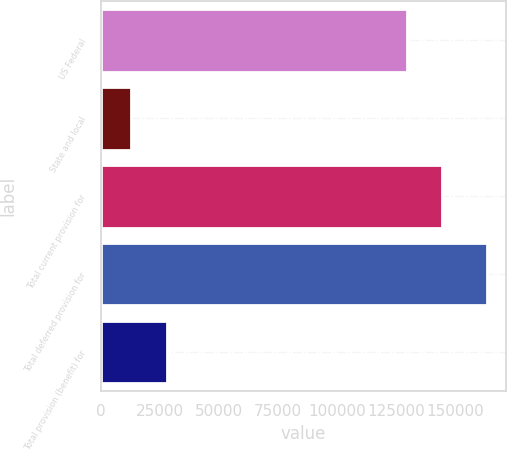Convert chart. <chart><loc_0><loc_0><loc_500><loc_500><bar_chart><fcel>US Federal<fcel>State and local<fcel>Total current provision for<fcel>Total deferred provision for<fcel>Total provision (benefit) for<nl><fcel>129633<fcel>12649<fcel>144723<fcel>163550<fcel>27739.1<nl></chart> 